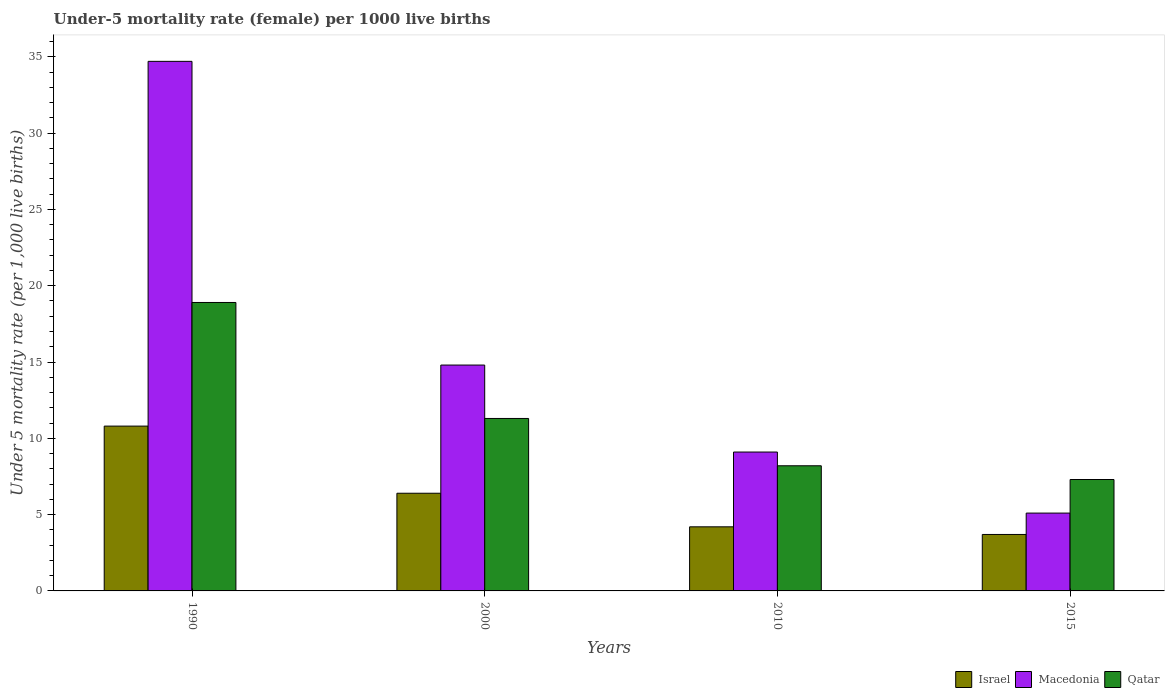How many different coloured bars are there?
Your answer should be very brief. 3. How many groups of bars are there?
Provide a short and direct response. 4. Are the number of bars per tick equal to the number of legend labels?
Ensure brevity in your answer.  Yes. In how many cases, is the number of bars for a given year not equal to the number of legend labels?
Your answer should be compact. 0. What is the under-five mortality rate in Macedonia in 2000?
Ensure brevity in your answer.  14.8. Across all years, what is the maximum under-five mortality rate in Macedonia?
Keep it short and to the point. 34.7. In which year was the under-five mortality rate in Macedonia maximum?
Your answer should be compact. 1990. In which year was the under-five mortality rate in Macedonia minimum?
Give a very brief answer. 2015. What is the total under-five mortality rate in Israel in the graph?
Offer a very short reply. 25.1. What is the difference between the under-five mortality rate in Macedonia in 1990 and that in 2015?
Ensure brevity in your answer.  29.6. What is the difference between the under-five mortality rate in Macedonia in 2015 and the under-five mortality rate in Israel in 1990?
Your response must be concise. -5.7. What is the average under-five mortality rate in Qatar per year?
Provide a succinct answer. 11.42. What is the ratio of the under-five mortality rate in Macedonia in 1990 to that in 2000?
Your answer should be very brief. 2.34. What is the difference between the highest and the lowest under-five mortality rate in Israel?
Offer a terse response. 7.1. In how many years, is the under-five mortality rate in Macedonia greater than the average under-five mortality rate in Macedonia taken over all years?
Provide a short and direct response. 1. Is the sum of the under-five mortality rate in Macedonia in 2010 and 2015 greater than the maximum under-five mortality rate in Israel across all years?
Keep it short and to the point. Yes. What does the 3rd bar from the left in 2000 represents?
Give a very brief answer. Qatar. Are all the bars in the graph horizontal?
Your answer should be compact. No. How many years are there in the graph?
Keep it short and to the point. 4. Are the values on the major ticks of Y-axis written in scientific E-notation?
Offer a terse response. No. Does the graph contain any zero values?
Keep it short and to the point. No. Where does the legend appear in the graph?
Give a very brief answer. Bottom right. How many legend labels are there?
Offer a very short reply. 3. What is the title of the graph?
Your response must be concise. Under-5 mortality rate (female) per 1000 live births. What is the label or title of the X-axis?
Offer a terse response. Years. What is the label or title of the Y-axis?
Make the answer very short. Under 5 mortality rate (per 1,0 live births). What is the Under 5 mortality rate (per 1,000 live births) in Macedonia in 1990?
Your answer should be very brief. 34.7. What is the Under 5 mortality rate (per 1,000 live births) in Qatar in 1990?
Provide a succinct answer. 18.9. What is the Under 5 mortality rate (per 1,000 live births) of Qatar in 2000?
Offer a very short reply. 11.3. What is the Under 5 mortality rate (per 1,000 live births) in Israel in 2010?
Give a very brief answer. 4.2. What is the Under 5 mortality rate (per 1,000 live births) in Macedonia in 2010?
Offer a terse response. 9.1. What is the Under 5 mortality rate (per 1,000 live births) in Israel in 2015?
Your response must be concise. 3.7. What is the Under 5 mortality rate (per 1,000 live births) in Qatar in 2015?
Ensure brevity in your answer.  7.3. Across all years, what is the maximum Under 5 mortality rate (per 1,000 live births) of Israel?
Offer a terse response. 10.8. Across all years, what is the maximum Under 5 mortality rate (per 1,000 live births) of Macedonia?
Provide a short and direct response. 34.7. Across all years, what is the maximum Under 5 mortality rate (per 1,000 live births) in Qatar?
Ensure brevity in your answer.  18.9. Across all years, what is the minimum Under 5 mortality rate (per 1,000 live births) in Macedonia?
Offer a terse response. 5.1. Across all years, what is the minimum Under 5 mortality rate (per 1,000 live births) of Qatar?
Provide a short and direct response. 7.3. What is the total Under 5 mortality rate (per 1,000 live births) in Israel in the graph?
Provide a short and direct response. 25.1. What is the total Under 5 mortality rate (per 1,000 live births) in Macedonia in the graph?
Your answer should be very brief. 63.7. What is the total Under 5 mortality rate (per 1,000 live births) in Qatar in the graph?
Your response must be concise. 45.7. What is the difference between the Under 5 mortality rate (per 1,000 live births) in Israel in 1990 and that in 2000?
Your response must be concise. 4.4. What is the difference between the Under 5 mortality rate (per 1,000 live births) of Qatar in 1990 and that in 2000?
Make the answer very short. 7.6. What is the difference between the Under 5 mortality rate (per 1,000 live births) of Macedonia in 1990 and that in 2010?
Provide a succinct answer. 25.6. What is the difference between the Under 5 mortality rate (per 1,000 live births) in Israel in 1990 and that in 2015?
Keep it short and to the point. 7.1. What is the difference between the Under 5 mortality rate (per 1,000 live births) in Macedonia in 1990 and that in 2015?
Provide a short and direct response. 29.6. What is the difference between the Under 5 mortality rate (per 1,000 live births) in Qatar in 1990 and that in 2015?
Keep it short and to the point. 11.6. What is the difference between the Under 5 mortality rate (per 1,000 live births) in Macedonia in 2000 and that in 2010?
Your answer should be very brief. 5.7. What is the difference between the Under 5 mortality rate (per 1,000 live births) in Qatar in 2000 and that in 2010?
Ensure brevity in your answer.  3.1. What is the difference between the Under 5 mortality rate (per 1,000 live births) of Israel in 2000 and that in 2015?
Offer a terse response. 2.7. What is the difference between the Under 5 mortality rate (per 1,000 live births) in Qatar in 2000 and that in 2015?
Offer a very short reply. 4. What is the difference between the Under 5 mortality rate (per 1,000 live births) in Israel in 2010 and that in 2015?
Your answer should be very brief. 0.5. What is the difference between the Under 5 mortality rate (per 1,000 live births) of Israel in 1990 and the Under 5 mortality rate (per 1,000 live births) of Qatar in 2000?
Offer a terse response. -0.5. What is the difference between the Under 5 mortality rate (per 1,000 live births) in Macedonia in 1990 and the Under 5 mortality rate (per 1,000 live births) in Qatar in 2000?
Give a very brief answer. 23.4. What is the difference between the Under 5 mortality rate (per 1,000 live births) in Israel in 1990 and the Under 5 mortality rate (per 1,000 live births) in Qatar in 2010?
Offer a terse response. 2.6. What is the difference between the Under 5 mortality rate (per 1,000 live births) in Macedonia in 1990 and the Under 5 mortality rate (per 1,000 live births) in Qatar in 2010?
Your response must be concise. 26.5. What is the difference between the Under 5 mortality rate (per 1,000 live births) of Israel in 1990 and the Under 5 mortality rate (per 1,000 live births) of Qatar in 2015?
Your answer should be very brief. 3.5. What is the difference between the Under 5 mortality rate (per 1,000 live births) of Macedonia in 1990 and the Under 5 mortality rate (per 1,000 live births) of Qatar in 2015?
Make the answer very short. 27.4. What is the difference between the Under 5 mortality rate (per 1,000 live births) in Israel in 2000 and the Under 5 mortality rate (per 1,000 live births) in Macedonia in 2010?
Your answer should be very brief. -2.7. What is the difference between the Under 5 mortality rate (per 1,000 live births) in Israel in 2000 and the Under 5 mortality rate (per 1,000 live births) in Qatar in 2010?
Your answer should be very brief. -1.8. What is the difference between the Under 5 mortality rate (per 1,000 live births) in Israel in 2000 and the Under 5 mortality rate (per 1,000 live births) in Macedonia in 2015?
Make the answer very short. 1.3. What is the difference between the Under 5 mortality rate (per 1,000 live births) of Israel in 2000 and the Under 5 mortality rate (per 1,000 live births) of Qatar in 2015?
Make the answer very short. -0.9. What is the difference between the Under 5 mortality rate (per 1,000 live births) of Macedonia in 2000 and the Under 5 mortality rate (per 1,000 live births) of Qatar in 2015?
Your answer should be very brief. 7.5. What is the difference between the Under 5 mortality rate (per 1,000 live births) in Israel in 2010 and the Under 5 mortality rate (per 1,000 live births) in Qatar in 2015?
Ensure brevity in your answer.  -3.1. What is the average Under 5 mortality rate (per 1,000 live births) of Israel per year?
Keep it short and to the point. 6.28. What is the average Under 5 mortality rate (per 1,000 live births) in Macedonia per year?
Your response must be concise. 15.93. What is the average Under 5 mortality rate (per 1,000 live births) of Qatar per year?
Your answer should be very brief. 11.43. In the year 1990, what is the difference between the Under 5 mortality rate (per 1,000 live births) of Israel and Under 5 mortality rate (per 1,000 live births) of Macedonia?
Ensure brevity in your answer.  -23.9. In the year 2000, what is the difference between the Under 5 mortality rate (per 1,000 live births) of Israel and Under 5 mortality rate (per 1,000 live births) of Qatar?
Offer a terse response. -4.9. In the year 2000, what is the difference between the Under 5 mortality rate (per 1,000 live births) of Macedonia and Under 5 mortality rate (per 1,000 live births) of Qatar?
Offer a terse response. 3.5. In the year 2010, what is the difference between the Under 5 mortality rate (per 1,000 live births) in Israel and Under 5 mortality rate (per 1,000 live births) in Macedonia?
Ensure brevity in your answer.  -4.9. In the year 2015, what is the difference between the Under 5 mortality rate (per 1,000 live births) of Israel and Under 5 mortality rate (per 1,000 live births) of Macedonia?
Keep it short and to the point. -1.4. In the year 2015, what is the difference between the Under 5 mortality rate (per 1,000 live births) in Israel and Under 5 mortality rate (per 1,000 live births) in Qatar?
Provide a succinct answer. -3.6. In the year 2015, what is the difference between the Under 5 mortality rate (per 1,000 live births) in Macedonia and Under 5 mortality rate (per 1,000 live births) in Qatar?
Provide a short and direct response. -2.2. What is the ratio of the Under 5 mortality rate (per 1,000 live births) in Israel in 1990 to that in 2000?
Provide a succinct answer. 1.69. What is the ratio of the Under 5 mortality rate (per 1,000 live births) in Macedonia in 1990 to that in 2000?
Ensure brevity in your answer.  2.34. What is the ratio of the Under 5 mortality rate (per 1,000 live births) in Qatar in 1990 to that in 2000?
Keep it short and to the point. 1.67. What is the ratio of the Under 5 mortality rate (per 1,000 live births) of Israel in 1990 to that in 2010?
Provide a short and direct response. 2.57. What is the ratio of the Under 5 mortality rate (per 1,000 live births) of Macedonia in 1990 to that in 2010?
Ensure brevity in your answer.  3.81. What is the ratio of the Under 5 mortality rate (per 1,000 live births) of Qatar in 1990 to that in 2010?
Your response must be concise. 2.3. What is the ratio of the Under 5 mortality rate (per 1,000 live births) in Israel in 1990 to that in 2015?
Provide a succinct answer. 2.92. What is the ratio of the Under 5 mortality rate (per 1,000 live births) of Macedonia in 1990 to that in 2015?
Your answer should be very brief. 6.8. What is the ratio of the Under 5 mortality rate (per 1,000 live births) in Qatar in 1990 to that in 2015?
Provide a succinct answer. 2.59. What is the ratio of the Under 5 mortality rate (per 1,000 live births) in Israel in 2000 to that in 2010?
Ensure brevity in your answer.  1.52. What is the ratio of the Under 5 mortality rate (per 1,000 live births) in Macedonia in 2000 to that in 2010?
Offer a terse response. 1.63. What is the ratio of the Under 5 mortality rate (per 1,000 live births) in Qatar in 2000 to that in 2010?
Provide a succinct answer. 1.38. What is the ratio of the Under 5 mortality rate (per 1,000 live births) in Israel in 2000 to that in 2015?
Offer a very short reply. 1.73. What is the ratio of the Under 5 mortality rate (per 1,000 live births) of Macedonia in 2000 to that in 2015?
Your answer should be compact. 2.9. What is the ratio of the Under 5 mortality rate (per 1,000 live births) of Qatar in 2000 to that in 2015?
Provide a succinct answer. 1.55. What is the ratio of the Under 5 mortality rate (per 1,000 live births) in Israel in 2010 to that in 2015?
Offer a terse response. 1.14. What is the ratio of the Under 5 mortality rate (per 1,000 live births) of Macedonia in 2010 to that in 2015?
Your answer should be very brief. 1.78. What is the ratio of the Under 5 mortality rate (per 1,000 live births) in Qatar in 2010 to that in 2015?
Make the answer very short. 1.12. What is the difference between the highest and the lowest Under 5 mortality rate (per 1,000 live births) in Israel?
Your answer should be very brief. 7.1. What is the difference between the highest and the lowest Under 5 mortality rate (per 1,000 live births) of Macedonia?
Offer a terse response. 29.6. 